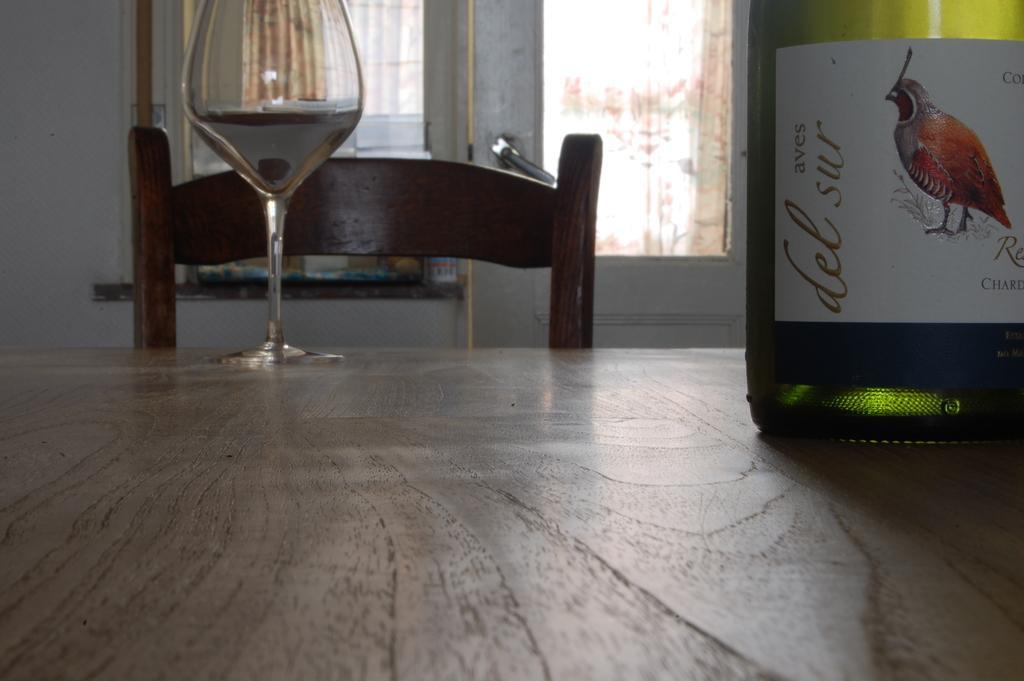In one or two sentences, can you explain what this image depicts? In this picture there is a wine glass kept on the table and is wine bottle is also there in in in in the background there is a door and window 